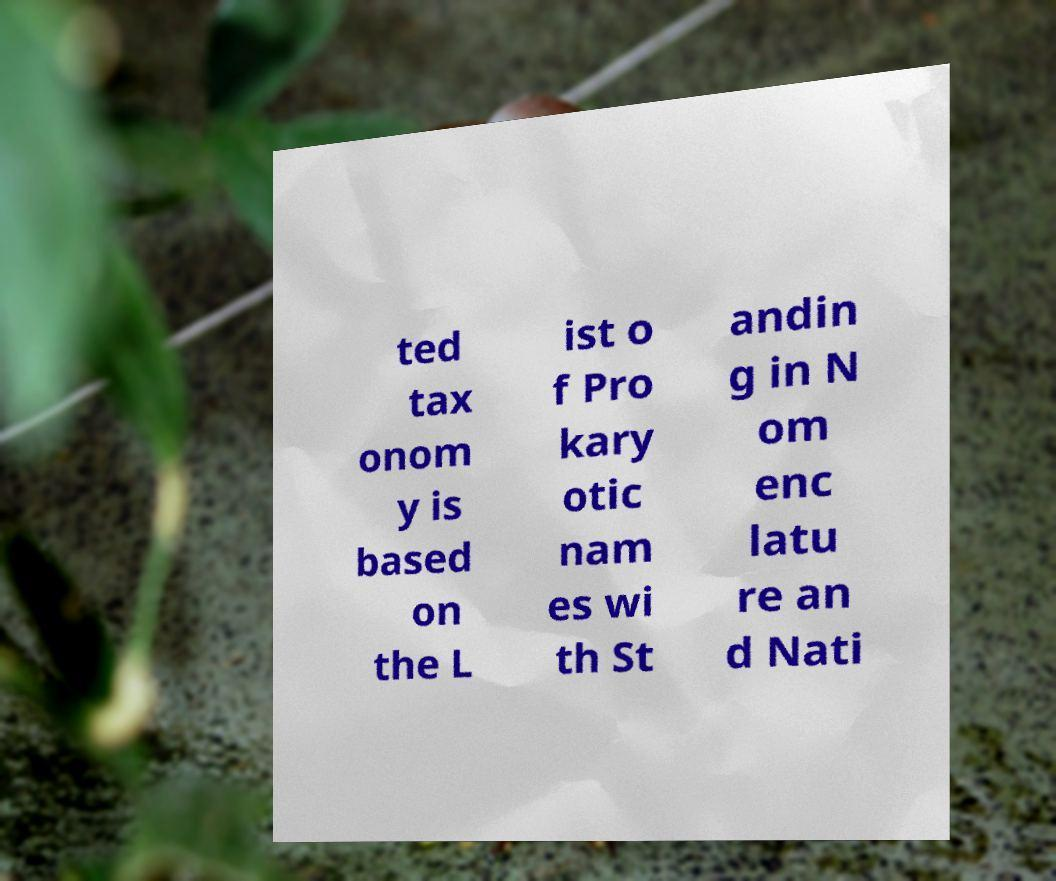Could you assist in decoding the text presented in this image and type it out clearly? ted tax onom y is based on the L ist o f Pro kary otic nam es wi th St andin g in N om enc latu re an d Nati 